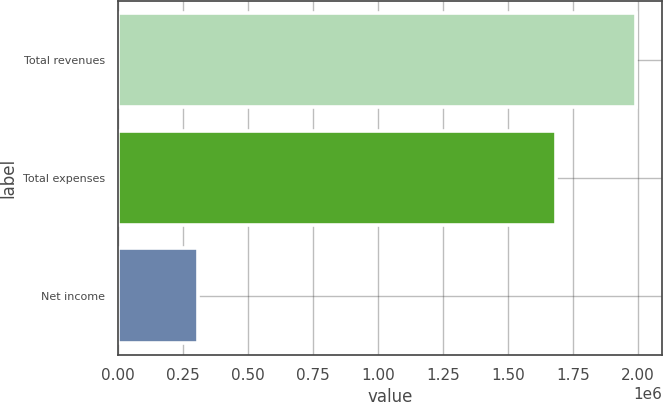Convert chart to OTSL. <chart><loc_0><loc_0><loc_500><loc_500><bar_chart><fcel>Total revenues<fcel>Total expenses<fcel>Net income<nl><fcel>1.99401e+06<fcel>1.68428e+06<fcel>309738<nl></chart> 